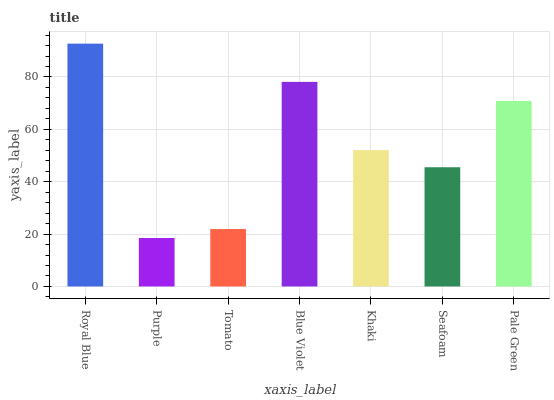Is Purple the minimum?
Answer yes or no. Yes. Is Royal Blue the maximum?
Answer yes or no. Yes. Is Tomato the minimum?
Answer yes or no. No. Is Tomato the maximum?
Answer yes or no. No. Is Tomato greater than Purple?
Answer yes or no. Yes. Is Purple less than Tomato?
Answer yes or no. Yes. Is Purple greater than Tomato?
Answer yes or no. No. Is Tomato less than Purple?
Answer yes or no. No. Is Khaki the high median?
Answer yes or no. Yes. Is Khaki the low median?
Answer yes or no. Yes. Is Blue Violet the high median?
Answer yes or no. No. Is Royal Blue the low median?
Answer yes or no. No. 